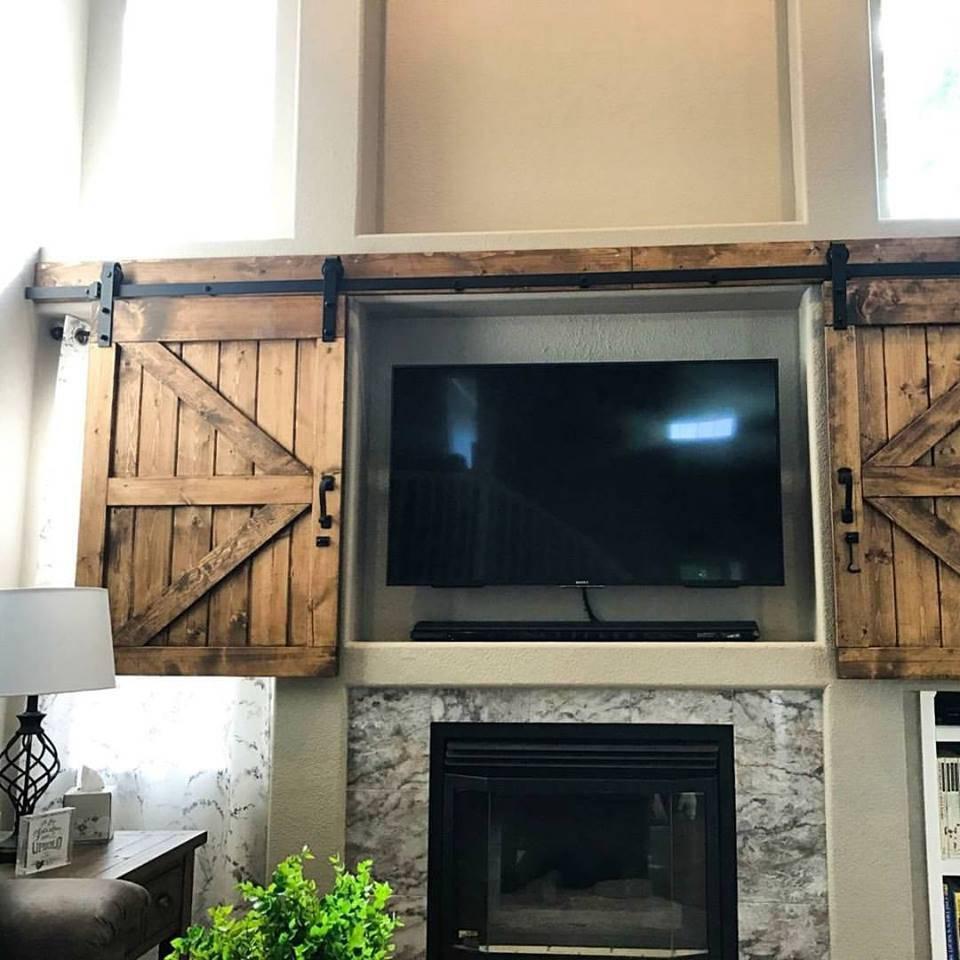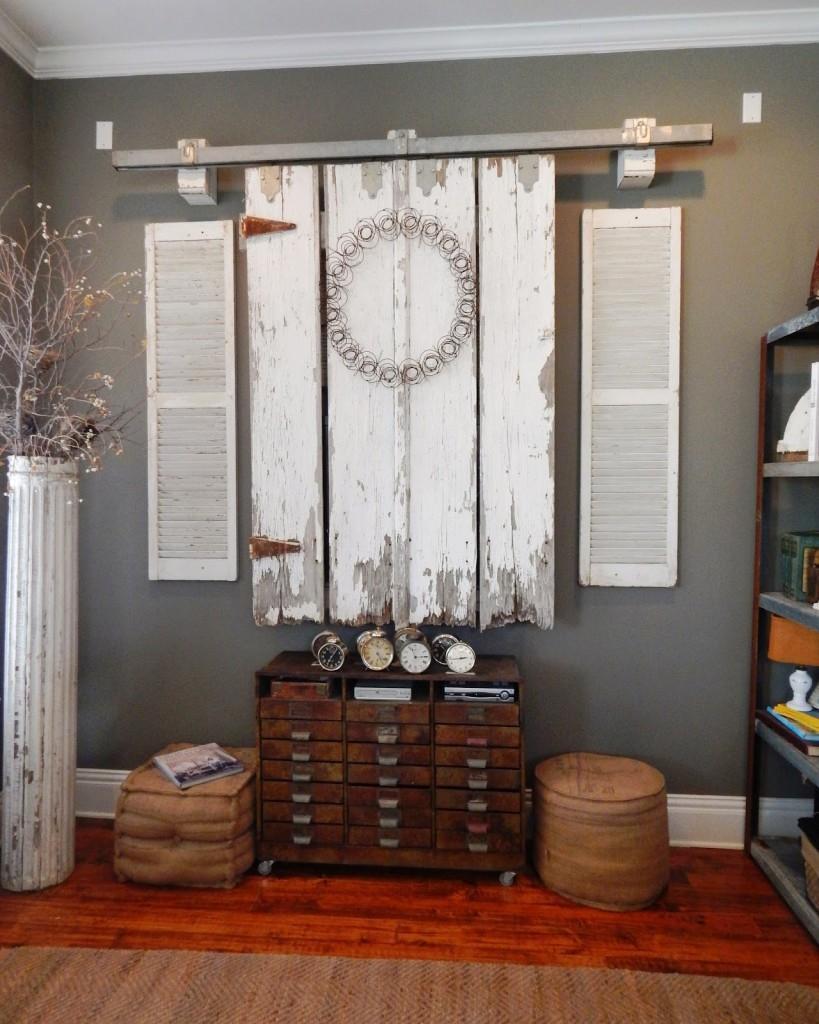The first image is the image on the left, the second image is the image on the right. For the images displayed, is the sentence "A sliding television cabinet is open." factually correct? Answer yes or no. Yes. The first image is the image on the left, the second image is the image on the right. Evaluate the accuracy of this statement regarding the images: "An image shows 'barn doors' that slide on a black bar overhead, above a wide dresser with lamps on each end.". Is it true? Answer yes or no. No. 